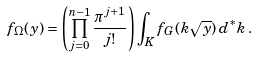<formula> <loc_0><loc_0><loc_500><loc_500>f _ { \Omega } ( y ) = \left ( \prod _ { j = 0 } ^ { n - 1 } \frac { \pi ^ { j + 1 } } { j ! } \right ) \int _ { K } f _ { G } ( k \sqrt { y } ) \, d ^ { * } k \, .</formula> 